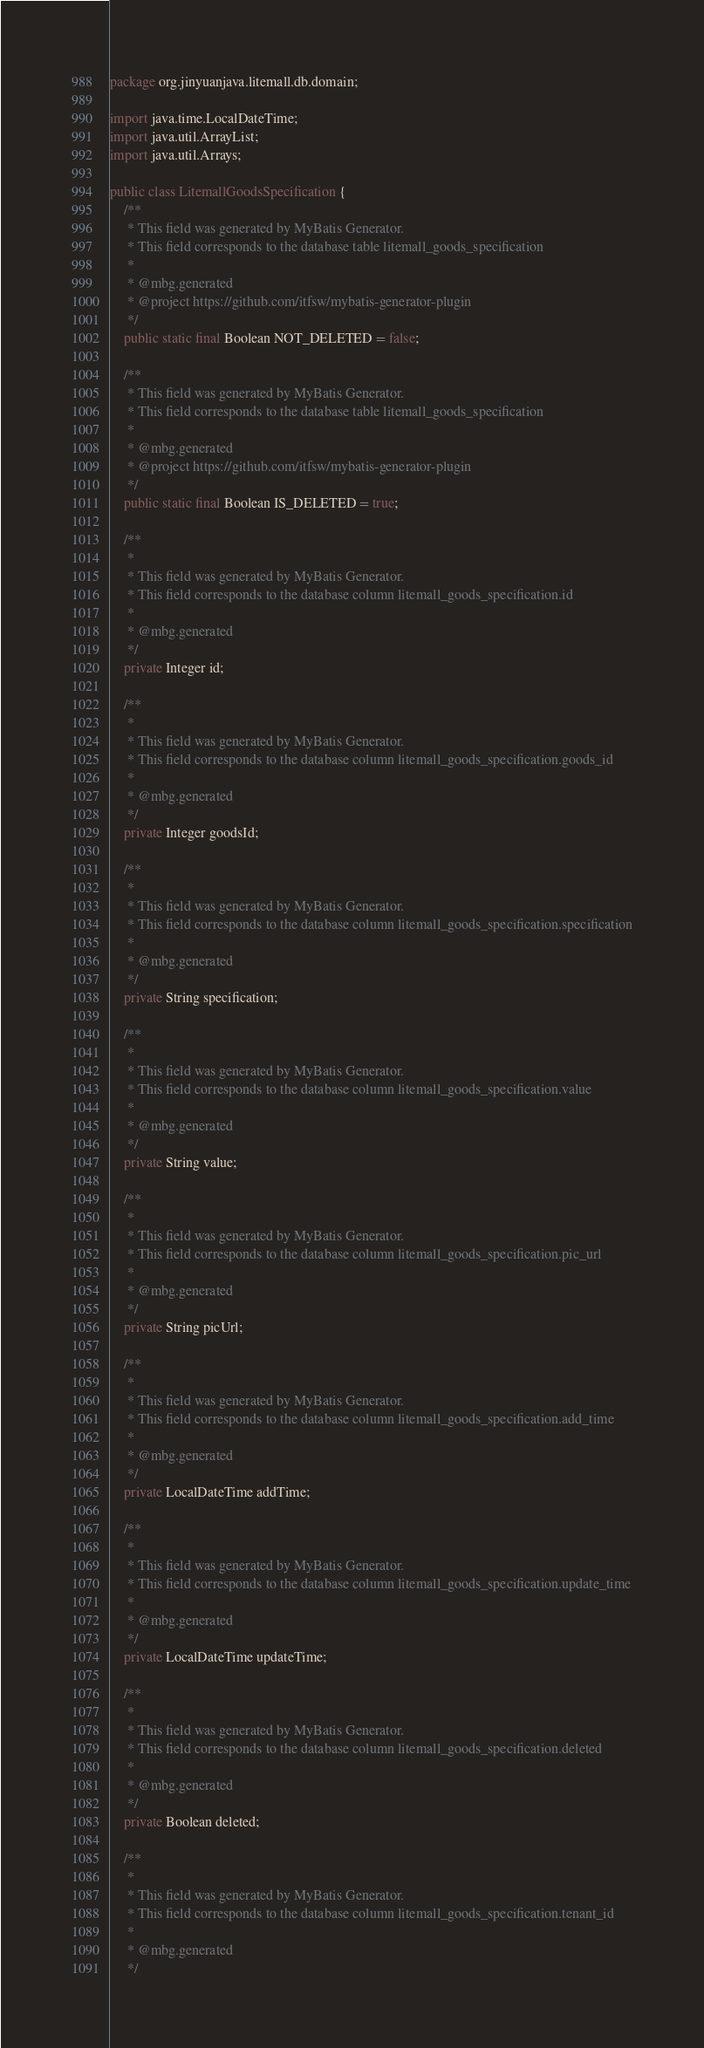Convert code to text. <code><loc_0><loc_0><loc_500><loc_500><_Java_>package org.jinyuanjava.litemall.db.domain;

import java.time.LocalDateTime;
import java.util.ArrayList;
import java.util.Arrays;

public class LitemallGoodsSpecification {
    /**
     * This field was generated by MyBatis Generator.
     * This field corresponds to the database table litemall_goods_specification
     *
     * @mbg.generated
     * @project https://github.com/itfsw/mybatis-generator-plugin
     */
    public static final Boolean NOT_DELETED = false;

    /**
     * This field was generated by MyBatis Generator.
     * This field corresponds to the database table litemall_goods_specification
     *
     * @mbg.generated
     * @project https://github.com/itfsw/mybatis-generator-plugin
     */
    public static final Boolean IS_DELETED = true;

    /**
     *
     * This field was generated by MyBatis Generator.
     * This field corresponds to the database column litemall_goods_specification.id
     *
     * @mbg.generated
     */
    private Integer id;

    /**
     *
     * This field was generated by MyBatis Generator.
     * This field corresponds to the database column litemall_goods_specification.goods_id
     *
     * @mbg.generated
     */
    private Integer goodsId;

    /**
     *
     * This field was generated by MyBatis Generator.
     * This field corresponds to the database column litemall_goods_specification.specification
     *
     * @mbg.generated
     */
    private String specification;

    /**
     *
     * This field was generated by MyBatis Generator.
     * This field corresponds to the database column litemall_goods_specification.value
     *
     * @mbg.generated
     */
    private String value;

    /**
     *
     * This field was generated by MyBatis Generator.
     * This field corresponds to the database column litemall_goods_specification.pic_url
     *
     * @mbg.generated
     */
    private String picUrl;

    /**
     *
     * This field was generated by MyBatis Generator.
     * This field corresponds to the database column litemall_goods_specification.add_time
     *
     * @mbg.generated
     */
    private LocalDateTime addTime;

    /**
     *
     * This field was generated by MyBatis Generator.
     * This field corresponds to the database column litemall_goods_specification.update_time
     *
     * @mbg.generated
     */
    private LocalDateTime updateTime;

    /**
     *
     * This field was generated by MyBatis Generator.
     * This field corresponds to the database column litemall_goods_specification.deleted
     *
     * @mbg.generated
     */
    private Boolean deleted;

    /**
     *
     * This field was generated by MyBatis Generator.
     * This field corresponds to the database column litemall_goods_specification.tenant_id
     *
     * @mbg.generated
     */</code> 